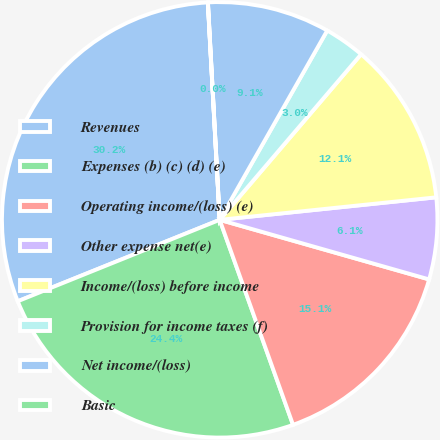Convert chart to OTSL. <chart><loc_0><loc_0><loc_500><loc_500><pie_chart><fcel>Revenues<fcel>Expenses (b) (c) (d) (e)<fcel>Operating income/(loss) (e)<fcel>Other expense net(e)<fcel>Income/(loss) before income<fcel>Provision for income taxes (f)<fcel>Net income/(loss)<fcel>Basic<nl><fcel>30.23%<fcel>24.37%<fcel>15.12%<fcel>6.06%<fcel>12.1%<fcel>3.03%<fcel>9.08%<fcel>0.01%<nl></chart> 